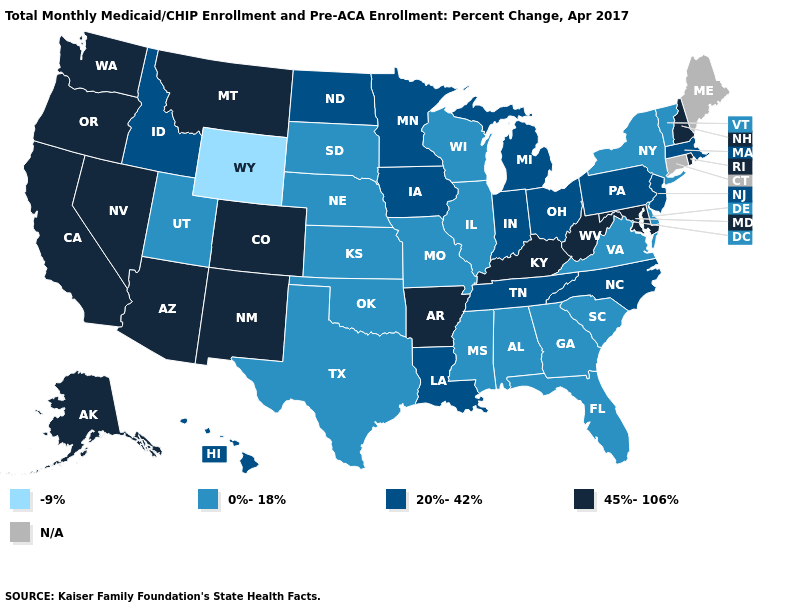Name the states that have a value in the range 20%-42%?
Write a very short answer. Hawaii, Idaho, Indiana, Iowa, Louisiana, Massachusetts, Michigan, Minnesota, New Jersey, North Carolina, North Dakota, Ohio, Pennsylvania, Tennessee. What is the value of New Jersey?
Concise answer only. 20%-42%. Among the states that border Alabama , which have the highest value?
Be succinct. Tennessee. Does the map have missing data?
Give a very brief answer. Yes. Is the legend a continuous bar?
Keep it brief. No. Does Georgia have the highest value in the USA?
Quick response, please. No. What is the value of Ohio?
Answer briefly. 20%-42%. What is the value of Mississippi?
Write a very short answer. 0%-18%. Name the states that have a value in the range 0%-18%?
Give a very brief answer. Alabama, Delaware, Florida, Georgia, Illinois, Kansas, Mississippi, Missouri, Nebraska, New York, Oklahoma, South Carolina, South Dakota, Texas, Utah, Vermont, Virginia, Wisconsin. Does Missouri have the highest value in the MidWest?
Short answer required. No. Which states have the lowest value in the MidWest?
Be succinct. Illinois, Kansas, Missouri, Nebraska, South Dakota, Wisconsin. What is the highest value in states that border Alabama?
Concise answer only. 20%-42%. Name the states that have a value in the range -9%?
Quick response, please. Wyoming. Name the states that have a value in the range N/A?
Short answer required. Connecticut, Maine. 